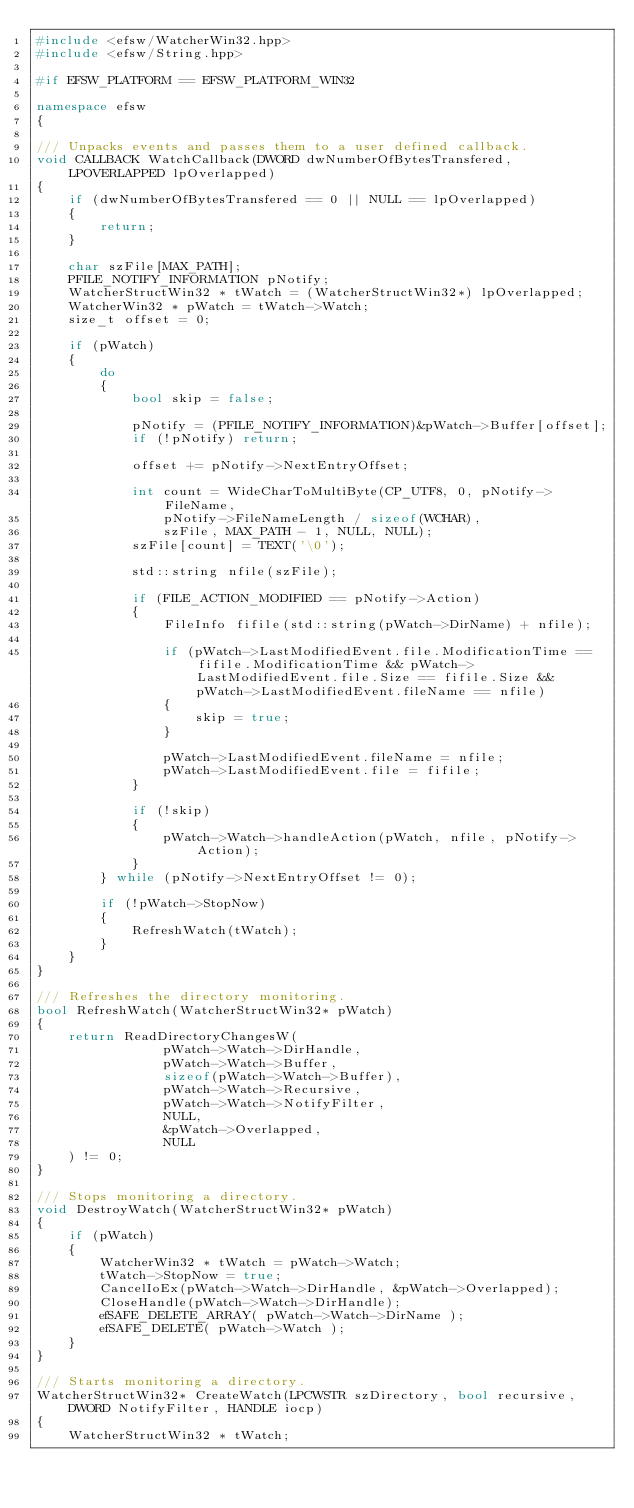Convert code to text. <code><loc_0><loc_0><loc_500><loc_500><_C++_>#include <efsw/WatcherWin32.hpp>
#include <efsw/String.hpp>

#if EFSW_PLATFORM == EFSW_PLATFORM_WIN32

namespace efsw
{

/// Unpacks events and passes them to a user defined callback.
void CALLBACK WatchCallback(DWORD dwNumberOfBytesTransfered, LPOVERLAPPED lpOverlapped)
{
	if (dwNumberOfBytesTransfered == 0 || NULL == lpOverlapped)
	{
		return;
	}

	char szFile[MAX_PATH];
	PFILE_NOTIFY_INFORMATION pNotify;
	WatcherStructWin32 * tWatch = (WatcherStructWin32*) lpOverlapped;
	WatcherWin32 * pWatch = tWatch->Watch;
	size_t offset = 0;

	if (pWatch)
	{
		do
		{
			bool skip = false;

			pNotify = (PFILE_NOTIFY_INFORMATION)&pWatch->Buffer[offset];
			if (!pNotify) return;

			offset += pNotify->NextEntryOffset;

			int count = WideCharToMultiByte(CP_UTF8, 0, pNotify->FileName,
				pNotify->FileNameLength / sizeof(WCHAR),
				szFile, MAX_PATH - 1, NULL, NULL);
			szFile[count] = TEXT('\0');

			std::string nfile(szFile);

			if (FILE_ACTION_MODIFIED == pNotify->Action)
			{
				FileInfo fifile(std::string(pWatch->DirName) + nfile);

				if (pWatch->LastModifiedEvent.file.ModificationTime == fifile.ModificationTime && pWatch->LastModifiedEvent.file.Size == fifile.Size && pWatch->LastModifiedEvent.fileName == nfile)
				{
					skip = true;
				}

				pWatch->LastModifiedEvent.fileName = nfile;
				pWatch->LastModifiedEvent.file = fifile;
			}

			if (!skip)
			{
				pWatch->Watch->handleAction(pWatch, nfile, pNotify->Action);
			}
		} while (pNotify->NextEntryOffset != 0);

		if (!pWatch->StopNow)
		{
			RefreshWatch(tWatch);
		}
	}
}

/// Refreshes the directory monitoring.
bool RefreshWatch(WatcherStructWin32* pWatch)
{
	return ReadDirectoryChangesW(
				pWatch->Watch->DirHandle,
				pWatch->Watch->Buffer,
				sizeof(pWatch->Watch->Buffer),
				pWatch->Watch->Recursive,
				pWatch->Watch->NotifyFilter,
				NULL,
				&pWatch->Overlapped,
				NULL
	) != 0;
}

/// Stops monitoring a directory.
void DestroyWatch(WatcherStructWin32* pWatch)
{
	if (pWatch)
	{
		WatcherWin32 * tWatch = pWatch->Watch;
		tWatch->StopNow = true;
		CancelIoEx(pWatch->Watch->DirHandle, &pWatch->Overlapped);
		CloseHandle(pWatch->Watch->DirHandle);
		efSAFE_DELETE_ARRAY( pWatch->Watch->DirName );
		efSAFE_DELETE( pWatch->Watch );
	}
}

/// Starts monitoring a directory.
WatcherStructWin32* CreateWatch(LPCWSTR szDirectory, bool recursive, DWORD NotifyFilter, HANDLE iocp)
{
	WatcherStructWin32 * tWatch;</code> 